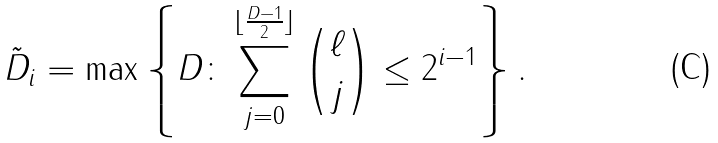<formula> <loc_0><loc_0><loc_500><loc_500>\tilde { D } _ { i } = \max \left \{ D \colon \sum _ { j = 0 } ^ { \lfloor \frac { D - 1 } { 2 } \rfloor } \binom { \ell } { j } \leq 2 ^ { i - 1 } \right \} .</formula> 